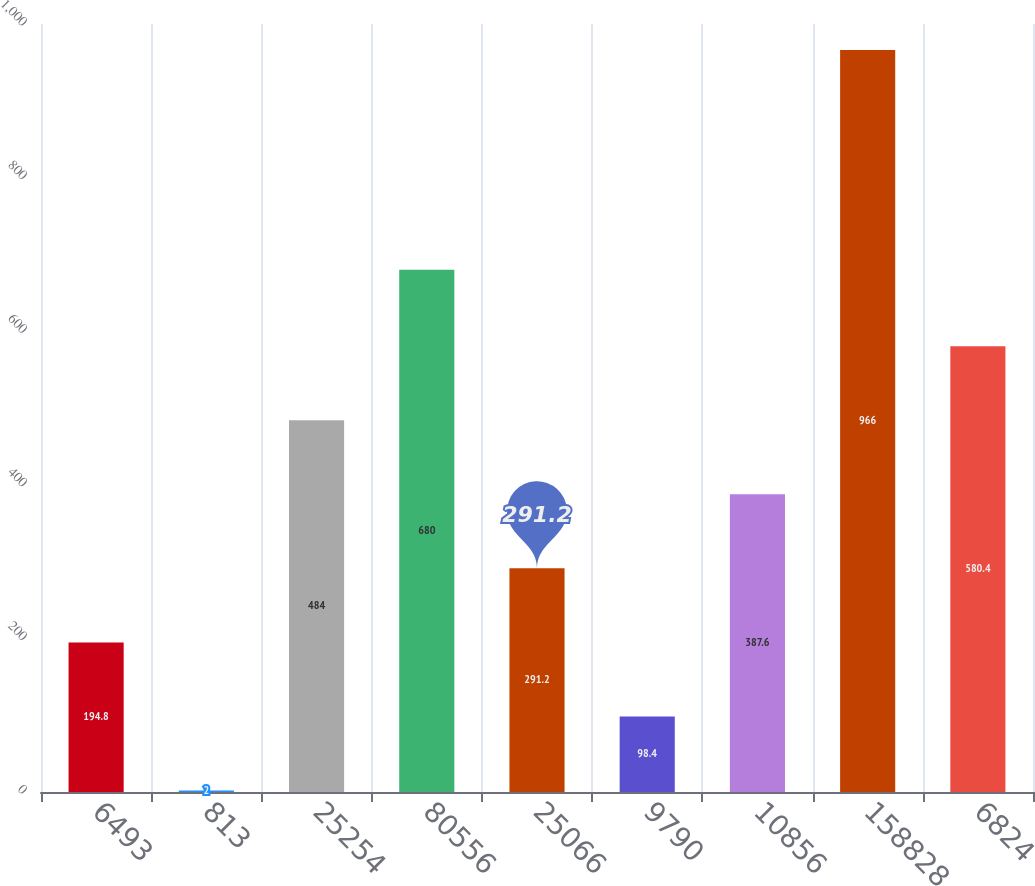Convert chart. <chart><loc_0><loc_0><loc_500><loc_500><bar_chart><fcel>6493<fcel>813<fcel>25254<fcel>80556<fcel>25066<fcel>9790<fcel>10856<fcel>158828<fcel>6824<nl><fcel>194.8<fcel>2<fcel>484<fcel>680<fcel>291.2<fcel>98.4<fcel>387.6<fcel>966<fcel>580.4<nl></chart> 